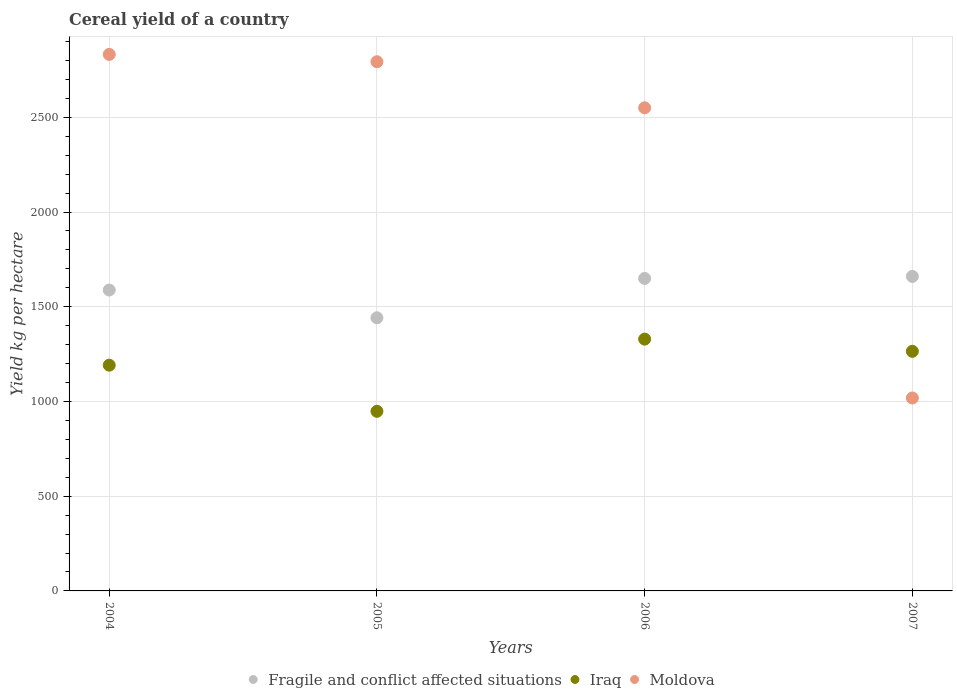What is the total cereal yield in Moldova in 2006?
Provide a succinct answer. 2550.18. Across all years, what is the maximum total cereal yield in Fragile and conflict affected situations?
Provide a short and direct response. 1660.23. Across all years, what is the minimum total cereal yield in Fragile and conflict affected situations?
Make the answer very short. 1441.77. In which year was the total cereal yield in Moldova minimum?
Keep it short and to the point. 2007. What is the total total cereal yield in Fragile and conflict affected situations in the graph?
Offer a terse response. 6339.82. What is the difference between the total cereal yield in Fragile and conflict affected situations in 2004 and that in 2005?
Keep it short and to the point. 146.61. What is the difference between the total cereal yield in Moldova in 2006 and the total cereal yield in Fragile and conflict affected situations in 2004?
Provide a short and direct response. 961.81. What is the average total cereal yield in Moldova per year?
Your answer should be very brief. 2298.51. In the year 2005, what is the difference between the total cereal yield in Moldova and total cereal yield in Fragile and conflict affected situations?
Keep it short and to the point. 1351.64. In how many years, is the total cereal yield in Moldova greater than 1200 kg per hectare?
Give a very brief answer. 3. What is the ratio of the total cereal yield in Iraq in 2006 to that in 2007?
Your response must be concise. 1.05. Is the difference between the total cereal yield in Moldova in 2006 and 2007 greater than the difference between the total cereal yield in Fragile and conflict affected situations in 2006 and 2007?
Keep it short and to the point. Yes. What is the difference between the highest and the second highest total cereal yield in Fragile and conflict affected situations?
Offer a very short reply. 10.78. What is the difference between the highest and the lowest total cereal yield in Fragile and conflict affected situations?
Keep it short and to the point. 218.46. Is the sum of the total cereal yield in Moldova in 2005 and 2006 greater than the maximum total cereal yield in Iraq across all years?
Provide a short and direct response. Yes. Is it the case that in every year, the sum of the total cereal yield in Iraq and total cereal yield in Moldova  is greater than the total cereal yield in Fragile and conflict affected situations?
Provide a short and direct response. Yes. Does the total cereal yield in Iraq monotonically increase over the years?
Provide a short and direct response. No. Is the total cereal yield in Moldova strictly greater than the total cereal yield in Iraq over the years?
Keep it short and to the point. No. How many dotlines are there?
Provide a succinct answer. 3. How many years are there in the graph?
Offer a very short reply. 4. Are the values on the major ticks of Y-axis written in scientific E-notation?
Provide a short and direct response. No. Does the graph contain any zero values?
Give a very brief answer. No. How are the legend labels stacked?
Keep it short and to the point. Horizontal. What is the title of the graph?
Your response must be concise. Cereal yield of a country. What is the label or title of the X-axis?
Offer a terse response. Years. What is the label or title of the Y-axis?
Give a very brief answer. Yield kg per hectare. What is the Yield kg per hectare in Fragile and conflict affected situations in 2004?
Offer a very short reply. 1588.37. What is the Yield kg per hectare in Iraq in 2004?
Ensure brevity in your answer.  1191.58. What is the Yield kg per hectare in Moldova in 2004?
Your answer should be compact. 2832.02. What is the Yield kg per hectare in Fragile and conflict affected situations in 2005?
Make the answer very short. 1441.77. What is the Yield kg per hectare of Iraq in 2005?
Provide a short and direct response. 948.13. What is the Yield kg per hectare of Moldova in 2005?
Give a very brief answer. 2793.41. What is the Yield kg per hectare of Fragile and conflict affected situations in 2006?
Offer a terse response. 1649.45. What is the Yield kg per hectare in Iraq in 2006?
Offer a very short reply. 1329.18. What is the Yield kg per hectare in Moldova in 2006?
Provide a succinct answer. 2550.18. What is the Yield kg per hectare of Fragile and conflict affected situations in 2007?
Provide a succinct answer. 1660.23. What is the Yield kg per hectare of Iraq in 2007?
Provide a succinct answer. 1264.84. What is the Yield kg per hectare in Moldova in 2007?
Provide a succinct answer. 1018.45. Across all years, what is the maximum Yield kg per hectare of Fragile and conflict affected situations?
Make the answer very short. 1660.23. Across all years, what is the maximum Yield kg per hectare in Iraq?
Keep it short and to the point. 1329.18. Across all years, what is the maximum Yield kg per hectare in Moldova?
Provide a succinct answer. 2832.02. Across all years, what is the minimum Yield kg per hectare in Fragile and conflict affected situations?
Provide a succinct answer. 1441.77. Across all years, what is the minimum Yield kg per hectare in Iraq?
Your answer should be very brief. 948.13. Across all years, what is the minimum Yield kg per hectare in Moldova?
Offer a very short reply. 1018.45. What is the total Yield kg per hectare in Fragile and conflict affected situations in the graph?
Provide a short and direct response. 6339.82. What is the total Yield kg per hectare in Iraq in the graph?
Offer a terse response. 4733.73. What is the total Yield kg per hectare of Moldova in the graph?
Offer a terse response. 9194.06. What is the difference between the Yield kg per hectare in Fragile and conflict affected situations in 2004 and that in 2005?
Give a very brief answer. 146.61. What is the difference between the Yield kg per hectare in Iraq in 2004 and that in 2005?
Ensure brevity in your answer.  243.45. What is the difference between the Yield kg per hectare of Moldova in 2004 and that in 2005?
Offer a very short reply. 38.61. What is the difference between the Yield kg per hectare in Fragile and conflict affected situations in 2004 and that in 2006?
Give a very brief answer. -61.07. What is the difference between the Yield kg per hectare in Iraq in 2004 and that in 2006?
Ensure brevity in your answer.  -137.6. What is the difference between the Yield kg per hectare of Moldova in 2004 and that in 2006?
Offer a terse response. 281.83. What is the difference between the Yield kg per hectare of Fragile and conflict affected situations in 2004 and that in 2007?
Provide a succinct answer. -71.86. What is the difference between the Yield kg per hectare of Iraq in 2004 and that in 2007?
Offer a very short reply. -73.26. What is the difference between the Yield kg per hectare in Moldova in 2004 and that in 2007?
Make the answer very short. 1813.57. What is the difference between the Yield kg per hectare in Fragile and conflict affected situations in 2005 and that in 2006?
Offer a terse response. -207.68. What is the difference between the Yield kg per hectare in Iraq in 2005 and that in 2006?
Offer a very short reply. -381.05. What is the difference between the Yield kg per hectare of Moldova in 2005 and that in 2006?
Keep it short and to the point. 243.22. What is the difference between the Yield kg per hectare in Fragile and conflict affected situations in 2005 and that in 2007?
Provide a short and direct response. -218.46. What is the difference between the Yield kg per hectare of Iraq in 2005 and that in 2007?
Give a very brief answer. -316.72. What is the difference between the Yield kg per hectare in Moldova in 2005 and that in 2007?
Offer a very short reply. 1774.96. What is the difference between the Yield kg per hectare in Fragile and conflict affected situations in 2006 and that in 2007?
Offer a very short reply. -10.78. What is the difference between the Yield kg per hectare in Iraq in 2006 and that in 2007?
Your answer should be very brief. 64.34. What is the difference between the Yield kg per hectare in Moldova in 2006 and that in 2007?
Make the answer very short. 1531.73. What is the difference between the Yield kg per hectare in Fragile and conflict affected situations in 2004 and the Yield kg per hectare in Iraq in 2005?
Provide a succinct answer. 640.25. What is the difference between the Yield kg per hectare of Fragile and conflict affected situations in 2004 and the Yield kg per hectare of Moldova in 2005?
Provide a short and direct response. -1205.03. What is the difference between the Yield kg per hectare in Iraq in 2004 and the Yield kg per hectare in Moldova in 2005?
Your answer should be very brief. -1601.83. What is the difference between the Yield kg per hectare of Fragile and conflict affected situations in 2004 and the Yield kg per hectare of Iraq in 2006?
Make the answer very short. 259.2. What is the difference between the Yield kg per hectare in Fragile and conflict affected situations in 2004 and the Yield kg per hectare in Moldova in 2006?
Give a very brief answer. -961.81. What is the difference between the Yield kg per hectare in Iraq in 2004 and the Yield kg per hectare in Moldova in 2006?
Keep it short and to the point. -1358.6. What is the difference between the Yield kg per hectare in Fragile and conflict affected situations in 2004 and the Yield kg per hectare in Iraq in 2007?
Ensure brevity in your answer.  323.53. What is the difference between the Yield kg per hectare in Fragile and conflict affected situations in 2004 and the Yield kg per hectare in Moldova in 2007?
Provide a short and direct response. 569.92. What is the difference between the Yield kg per hectare in Iraq in 2004 and the Yield kg per hectare in Moldova in 2007?
Your response must be concise. 173.13. What is the difference between the Yield kg per hectare of Fragile and conflict affected situations in 2005 and the Yield kg per hectare of Iraq in 2006?
Make the answer very short. 112.59. What is the difference between the Yield kg per hectare of Fragile and conflict affected situations in 2005 and the Yield kg per hectare of Moldova in 2006?
Your answer should be compact. -1108.42. What is the difference between the Yield kg per hectare in Iraq in 2005 and the Yield kg per hectare in Moldova in 2006?
Offer a terse response. -1602.06. What is the difference between the Yield kg per hectare in Fragile and conflict affected situations in 2005 and the Yield kg per hectare in Iraq in 2007?
Offer a very short reply. 176.92. What is the difference between the Yield kg per hectare of Fragile and conflict affected situations in 2005 and the Yield kg per hectare of Moldova in 2007?
Make the answer very short. 423.32. What is the difference between the Yield kg per hectare in Iraq in 2005 and the Yield kg per hectare in Moldova in 2007?
Offer a very short reply. -70.32. What is the difference between the Yield kg per hectare of Fragile and conflict affected situations in 2006 and the Yield kg per hectare of Iraq in 2007?
Your answer should be compact. 384.61. What is the difference between the Yield kg per hectare in Fragile and conflict affected situations in 2006 and the Yield kg per hectare in Moldova in 2007?
Your response must be concise. 631. What is the difference between the Yield kg per hectare of Iraq in 2006 and the Yield kg per hectare of Moldova in 2007?
Give a very brief answer. 310.73. What is the average Yield kg per hectare of Fragile and conflict affected situations per year?
Your answer should be very brief. 1584.95. What is the average Yield kg per hectare in Iraq per year?
Your answer should be compact. 1183.43. What is the average Yield kg per hectare in Moldova per year?
Offer a very short reply. 2298.51. In the year 2004, what is the difference between the Yield kg per hectare of Fragile and conflict affected situations and Yield kg per hectare of Iraq?
Keep it short and to the point. 396.79. In the year 2004, what is the difference between the Yield kg per hectare of Fragile and conflict affected situations and Yield kg per hectare of Moldova?
Make the answer very short. -1243.64. In the year 2004, what is the difference between the Yield kg per hectare of Iraq and Yield kg per hectare of Moldova?
Your answer should be very brief. -1640.44. In the year 2005, what is the difference between the Yield kg per hectare in Fragile and conflict affected situations and Yield kg per hectare in Iraq?
Keep it short and to the point. 493.64. In the year 2005, what is the difference between the Yield kg per hectare in Fragile and conflict affected situations and Yield kg per hectare in Moldova?
Your answer should be very brief. -1351.64. In the year 2005, what is the difference between the Yield kg per hectare of Iraq and Yield kg per hectare of Moldova?
Provide a short and direct response. -1845.28. In the year 2006, what is the difference between the Yield kg per hectare in Fragile and conflict affected situations and Yield kg per hectare in Iraq?
Give a very brief answer. 320.27. In the year 2006, what is the difference between the Yield kg per hectare of Fragile and conflict affected situations and Yield kg per hectare of Moldova?
Provide a short and direct response. -900.73. In the year 2006, what is the difference between the Yield kg per hectare in Iraq and Yield kg per hectare in Moldova?
Ensure brevity in your answer.  -1221.01. In the year 2007, what is the difference between the Yield kg per hectare in Fragile and conflict affected situations and Yield kg per hectare in Iraq?
Make the answer very short. 395.39. In the year 2007, what is the difference between the Yield kg per hectare of Fragile and conflict affected situations and Yield kg per hectare of Moldova?
Provide a succinct answer. 641.78. In the year 2007, what is the difference between the Yield kg per hectare in Iraq and Yield kg per hectare in Moldova?
Provide a short and direct response. 246.39. What is the ratio of the Yield kg per hectare of Fragile and conflict affected situations in 2004 to that in 2005?
Offer a very short reply. 1.1. What is the ratio of the Yield kg per hectare of Iraq in 2004 to that in 2005?
Your answer should be very brief. 1.26. What is the ratio of the Yield kg per hectare of Moldova in 2004 to that in 2005?
Your answer should be compact. 1.01. What is the ratio of the Yield kg per hectare of Fragile and conflict affected situations in 2004 to that in 2006?
Your response must be concise. 0.96. What is the ratio of the Yield kg per hectare of Iraq in 2004 to that in 2006?
Your response must be concise. 0.9. What is the ratio of the Yield kg per hectare of Moldova in 2004 to that in 2006?
Your answer should be compact. 1.11. What is the ratio of the Yield kg per hectare of Fragile and conflict affected situations in 2004 to that in 2007?
Give a very brief answer. 0.96. What is the ratio of the Yield kg per hectare of Iraq in 2004 to that in 2007?
Keep it short and to the point. 0.94. What is the ratio of the Yield kg per hectare of Moldova in 2004 to that in 2007?
Provide a succinct answer. 2.78. What is the ratio of the Yield kg per hectare of Fragile and conflict affected situations in 2005 to that in 2006?
Provide a short and direct response. 0.87. What is the ratio of the Yield kg per hectare of Iraq in 2005 to that in 2006?
Ensure brevity in your answer.  0.71. What is the ratio of the Yield kg per hectare of Moldova in 2005 to that in 2006?
Your answer should be very brief. 1.1. What is the ratio of the Yield kg per hectare of Fragile and conflict affected situations in 2005 to that in 2007?
Your answer should be compact. 0.87. What is the ratio of the Yield kg per hectare of Iraq in 2005 to that in 2007?
Ensure brevity in your answer.  0.75. What is the ratio of the Yield kg per hectare in Moldova in 2005 to that in 2007?
Offer a very short reply. 2.74. What is the ratio of the Yield kg per hectare in Iraq in 2006 to that in 2007?
Provide a succinct answer. 1.05. What is the ratio of the Yield kg per hectare in Moldova in 2006 to that in 2007?
Give a very brief answer. 2.5. What is the difference between the highest and the second highest Yield kg per hectare of Fragile and conflict affected situations?
Your answer should be very brief. 10.78. What is the difference between the highest and the second highest Yield kg per hectare in Iraq?
Provide a short and direct response. 64.34. What is the difference between the highest and the second highest Yield kg per hectare in Moldova?
Offer a very short reply. 38.61. What is the difference between the highest and the lowest Yield kg per hectare of Fragile and conflict affected situations?
Ensure brevity in your answer.  218.46. What is the difference between the highest and the lowest Yield kg per hectare in Iraq?
Provide a short and direct response. 381.05. What is the difference between the highest and the lowest Yield kg per hectare in Moldova?
Your answer should be compact. 1813.57. 